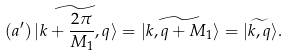<formula> <loc_0><loc_0><loc_500><loc_500>( a ^ { \prime } ) \, | \widetilde { k + \frac { 2 \pi } { M _ { 1 } } , q } \rangle = | \widetilde { k , q + M _ { 1 } } \rangle = | \widetilde { k , q } \rangle .</formula> 